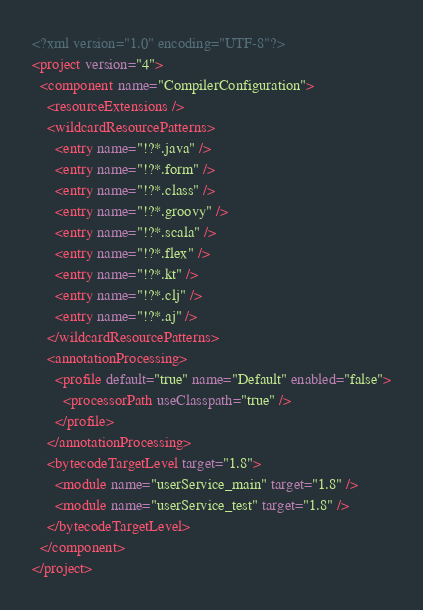<code> <loc_0><loc_0><loc_500><loc_500><_XML_><?xml version="1.0" encoding="UTF-8"?>
<project version="4">
  <component name="CompilerConfiguration">
    <resourceExtensions />
    <wildcardResourcePatterns>
      <entry name="!?*.java" />
      <entry name="!?*.form" />
      <entry name="!?*.class" />
      <entry name="!?*.groovy" />
      <entry name="!?*.scala" />
      <entry name="!?*.flex" />
      <entry name="!?*.kt" />
      <entry name="!?*.clj" />
      <entry name="!?*.aj" />
    </wildcardResourcePatterns>
    <annotationProcessing>
      <profile default="true" name="Default" enabled="false">
        <processorPath useClasspath="true" />
      </profile>
    </annotationProcessing>
    <bytecodeTargetLevel target="1.8">
      <module name="userService_main" target="1.8" />
      <module name="userService_test" target="1.8" />
    </bytecodeTargetLevel>
  </component>
</project></code> 